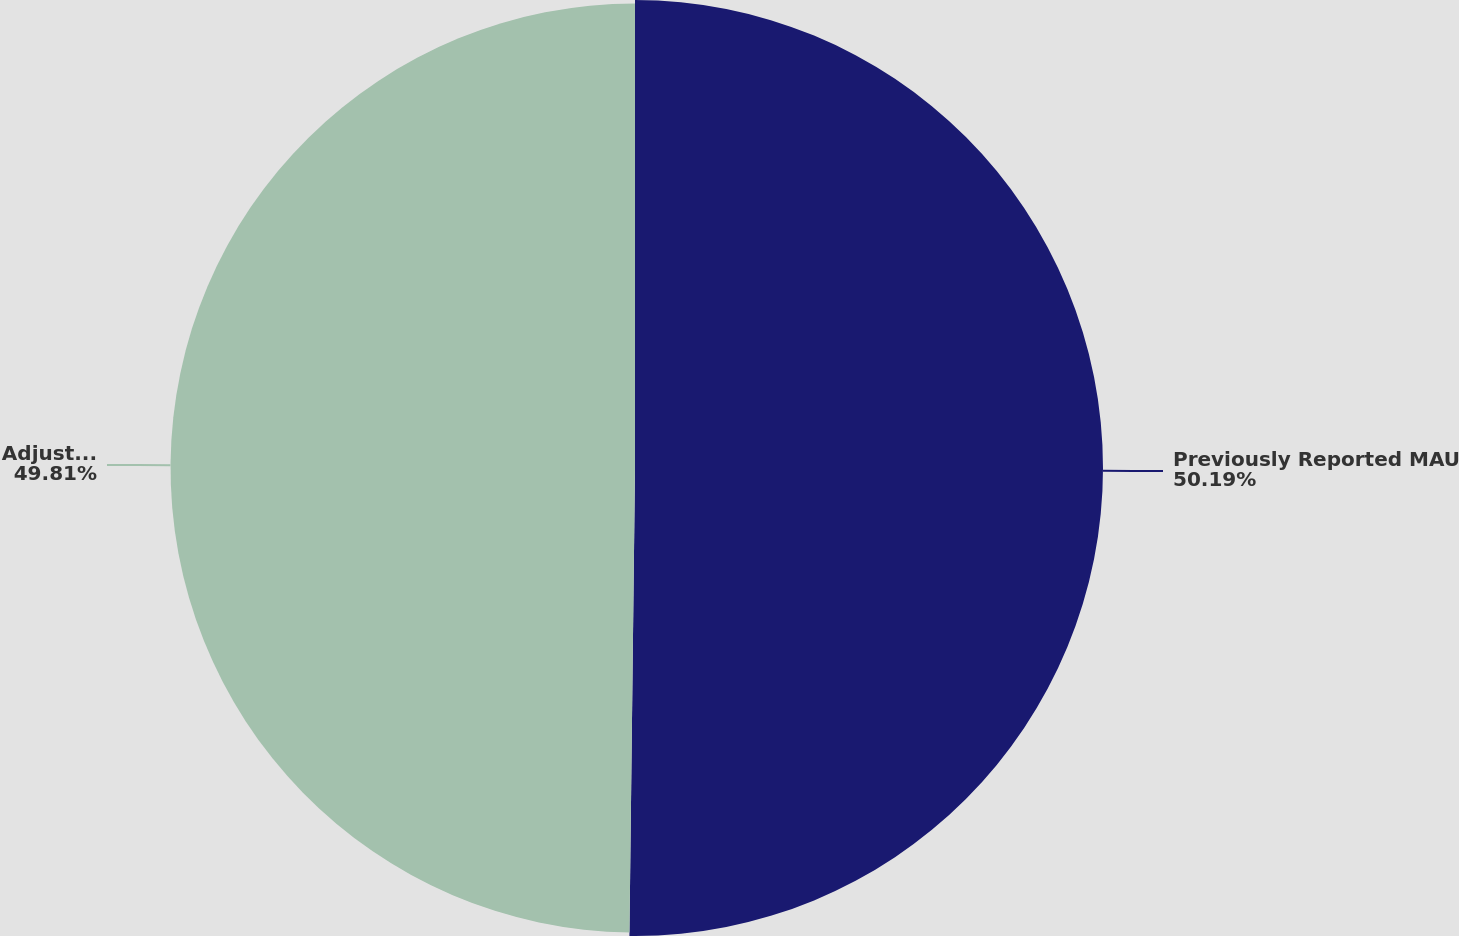<chart> <loc_0><loc_0><loc_500><loc_500><pie_chart><fcel>Previously Reported MAU<fcel>Adjusted MAU<nl><fcel>50.19%<fcel>49.81%<nl></chart> 